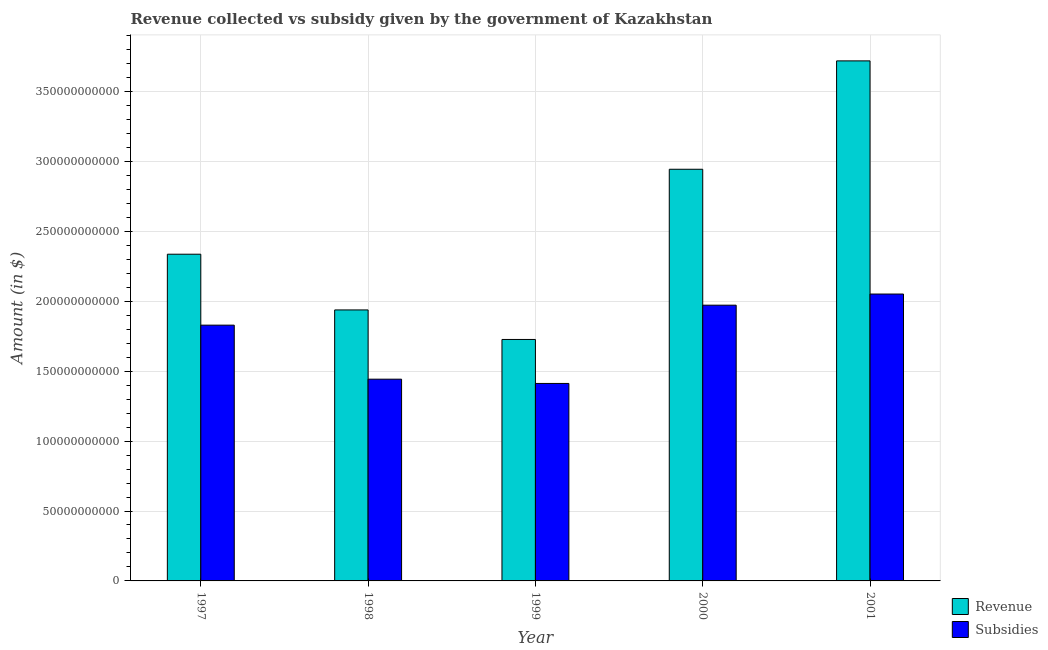How many different coloured bars are there?
Provide a short and direct response. 2. Are the number of bars on each tick of the X-axis equal?
Give a very brief answer. Yes. How many bars are there on the 3rd tick from the left?
Keep it short and to the point. 2. How many bars are there on the 1st tick from the right?
Offer a very short reply. 2. What is the label of the 2nd group of bars from the left?
Your answer should be compact. 1998. What is the amount of subsidies given in 1999?
Give a very brief answer. 1.41e+11. Across all years, what is the maximum amount of subsidies given?
Ensure brevity in your answer.  2.05e+11. Across all years, what is the minimum amount of revenue collected?
Ensure brevity in your answer.  1.73e+11. In which year was the amount of revenue collected maximum?
Ensure brevity in your answer.  2001. What is the total amount of revenue collected in the graph?
Provide a succinct answer. 1.27e+12. What is the difference between the amount of subsidies given in 1998 and that in 2000?
Your response must be concise. -5.29e+1. What is the difference between the amount of subsidies given in 1997 and the amount of revenue collected in 2001?
Your answer should be compact. -2.23e+1. What is the average amount of subsidies given per year?
Make the answer very short. 1.74e+11. In the year 2000, what is the difference between the amount of subsidies given and amount of revenue collected?
Provide a succinct answer. 0. What is the ratio of the amount of subsidies given in 2000 to that in 2001?
Make the answer very short. 0.96. Is the amount of revenue collected in 1999 less than that in 2000?
Provide a succinct answer. Yes. What is the difference between the highest and the second highest amount of revenue collected?
Make the answer very short. 7.75e+1. What is the difference between the highest and the lowest amount of revenue collected?
Make the answer very short. 1.99e+11. What does the 2nd bar from the left in 1999 represents?
Provide a succinct answer. Subsidies. What does the 1st bar from the right in 1998 represents?
Provide a succinct answer. Subsidies. How many bars are there?
Keep it short and to the point. 10. How many years are there in the graph?
Your answer should be compact. 5. Are the values on the major ticks of Y-axis written in scientific E-notation?
Your response must be concise. No. Does the graph contain grids?
Keep it short and to the point. Yes. What is the title of the graph?
Provide a short and direct response. Revenue collected vs subsidy given by the government of Kazakhstan. Does "From World Bank" appear as one of the legend labels in the graph?
Provide a short and direct response. No. What is the label or title of the Y-axis?
Keep it short and to the point. Amount (in $). What is the Amount (in $) of Revenue in 1997?
Provide a succinct answer. 2.34e+11. What is the Amount (in $) of Subsidies in 1997?
Keep it short and to the point. 1.83e+11. What is the Amount (in $) in Revenue in 1998?
Your answer should be very brief. 1.94e+11. What is the Amount (in $) of Subsidies in 1998?
Provide a succinct answer. 1.44e+11. What is the Amount (in $) in Revenue in 1999?
Offer a very short reply. 1.73e+11. What is the Amount (in $) of Subsidies in 1999?
Ensure brevity in your answer.  1.41e+11. What is the Amount (in $) of Revenue in 2000?
Offer a terse response. 2.94e+11. What is the Amount (in $) in Subsidies in 2000?
Give a very brief answer. 1.97e+11. What is the Amount (in $) of Revenue in 2001?
Your answer should be very brief. 3.72e+11. What is the Amount (in $) in Subsidies in 2001?
Your answer should be very brief. 2.05e+11. Across all years, what is the maximum Amount (in $) in Revenue?
Provide a short and direct response. 3.72e+11. Across all years, what is the maximum Amount (in $) in Subsidies?
Ensure brevity in your answer.  2.05e+11. Across all years, what is the minimum Amount (in $) in Revenue?
Ensure brevity in your answer.  1.73e+11. Across all years, what is the minimum Amount (in $) of Subsidies?
Keep it short and to the point. 1.41e+11. What is the total Amount (in $) in Revenue in the graph?
Your answer should be very brief. 1.27e+12. What is the total Amount (in $) in Subsidies in the graph?
Provide a succinct answer. 8.71e+11. What is the difference between the Amount (in $) in Revenue in 1997 and that in 1998?
Offer a terse response. 3.99e+1. What is the difference between the Amount (in $) of Subsidies in 1997 and that in 1998?
Make the answer very short. 3.86e+1. What is the difference between the Amount (in $) of Revenue in 1997 and that in 1999?
Offer a very short reply. 6.10e+1. What is the difference between the Amount (in $) of Subsidies in 1997 and that in 1999?
Give a very brief answer. 4.17e+1. What is the difference between the Amount (in $) of Revenue in 1997 and that in 2000?
Provide a short and direct response. -6.08e+1. What is the difference between the Amount (in $) in Subsidies in 1997 and that in 2000?
Your answer should be compact. -1.43e+1. What is the difference between the Amount (in $) in Revenue in 1997 and that in 2001?
Make the answer very short. -1.38e+11. What is the difference between the Amount (in $) of Subsidies in 1997 and that in 2001?
Keep it short and to the point. -2.23e+1. What is the difference between the Amount (in $) of Revenue in 1998 and that in 1999?
Make the answer very short. 2.11e+1. What is the difference between the Amount (in $) of Subsidies in 1998 and that in 1999?
Keep it short and to the point. 3.05e+09. What is the difference between the Amount (in $) in Revenue in 1998 and that in 2000?
Offer a terse response. -1.01e+11. What is the difference between the Amount (in $) in Subsidies in 1998 and that in 2000?
Give a very brief answer. -5.29e+1. What is the difference between the Amount (in $) of Revenue in 1998 and that in 2001?
Your answer should be compact. -1.78e+11. What is the difference between the Amount (in $) of Subsidies in 1998 and that in 2001?
Ensure brevity in your answer.  -6.09e+1. What is the difference between the Amount (in $) of Revenue in 1999 and that in 2000?
Provide a short and direct response. -1.22e+11. What is the difference between the Amount (in $) in Subsidies in 1999 and that in 2000?
Ensure brevity in your answer.  -5.60e+1. What is the difference between the Amount (in $) in Revenue in 1999 and that in 2001?
Give a very brief answer. -1.99e+11. What is the difference between the Amount (in $) of Subsidies in 1999 and that in 2001?
Give a very brief answer. -6.40e+1. What is the difference between the Amount (in $) in Revenue in 2000 and that in 2001?
Provide a succinct answer. -7.75e+1. What is the difference between the Amount (in $) in Subsidies in 2000 and that in 2001?
Ensure brevity in your answer.  -7.97e+09. What is the difference between the Amount (in $) in Revenue in 1997 and the Amount (in $) in Subsidies in 1998?
Provide a succinct answer. 8.94e+1. What is the difference between the Amount (in $) of Revenue in 1997 and the Amount (in $) of Subsidies in 1999?
Ensure brevity in your answer.  9.24e+1. What is the difference between the Amount (in $) in Revenue in 1997 and the Amount (in $) in Subsidies in 2000?
Provide a short and direct response. 3.65e+1. What is the difference between the Amount (in $) of Revenue in 1997 and the Amount (in $) of Subsidies in 2001?
Your answer should be compact. 2.85e+1. What is the difference between the Amount (in $) of Revenue in 1998 and the Amount (in $) of Subsidies in 1999?
Make the answer very short. 5.26e+1. What is the difference between the Amount (in $) in Revenue in 1998 and the Amount (in $) in Subsidies in 2000?
Your answer should be compact. -3.40e+09. What is the difference between the Amount (in $) of Revenue in 1998 and the Amount (in $) of Subsidies in 2001?
Offer a very short reply. -1.14e+1. What is the difference between the Amount (in $) in Revenue in 1999 and the Amount (in $) in Subsidies in 2000?
Offer a terse response. -2.45e+1. What is the difference between the Amount (in $) of Revenue in 1999 and the Amount (in $) of Subsidies in 2001?
Your answer should be compact. -3.25e+1. What is the difference between the Amount (in $) of Revenue in 2000 and the Amount (in $) of Subsidies in 2001?
Make the answer very short. 8.93e+1. What is the average Amount (in $) in Revenue per year?
Give a very brief answer. 2.53e+11. What is the average Amount (in $) in Subsidies per year?
Your answer should be very brief. 1.74e+11. In the year 1997, what is the difference between the Amount (in $) in Revenue and Amount (in $) in Subsidies?
Your response must be concise. 5.07e+1. In the year 1998, what is the difference between the Amount (in $) of Revenue and Amount (in $) of Subsidies?
Offer a terse response. 4.95e+1. In the year 1999, what is the difference between the Amount (in $) of Revenue and Amount (in $) of Subsidies?
Give a very brief answer. 3.15e+1. In the year 2000, what is the difference between the Amount (in $) in Revenue and Amount (in $) in Subsidies?
Provide a short and direct response. 9.72e+1. In the year 2001, what is the difference between the Amount (in $) in Revenue and Amount (in $) in Subsidies?
Give a very brief answer. 1.67e+11. What is the ratio of the Amount (in $) of Revenue in 1997 to that in 1998?
Your response must be concise. 1.21. What is the ratio of the Amount (in $) of Subsidies in 1997 to that in 1998?
Offer a very short reply. 1.27. What is the ratio of the Amount (in $) in Revenue in 1997 to that in 1999?
Provide a short and direct response. 1.35. What is the ratio of the Amount (in $) in Subsidies in 1997 to that in 1999?
Keep it short and to the point. 1.3. What is the ratio of the Amount (in $) in Revenue in 1997 to that in 2000?
Offer a very short reply. 0.79. What is the ratio of the Amount (in $) in Subsidies in 1997 to that in 2000?
Provide a succinct answer. 0.93. What is the ratio of the Amount (in $) of Revenue in 1997 to that in 2001?
Give a very brief answer. 0.63. What is the ratio of the Amount (in $) of Subsidies in 1997 to that in 2001?
Make the answer very short. 0.89. What is the ratio of the Amount (in $) of Revenue in 1998 to that in 1999?
Provide a short and direct response. 1.12. What is the ratio of the Amount (in $) in Subsidies in 1998 to that in 1999?
Your answer should be compact. 1.02. What is the ratio of the Amount (in $) of Revenue in 1998 to that in 2000?
Offer a terse response. 0.66. What is the ratio of the Amount (in $) of Subsidies in 1998 to that in 2000?
Ensure brevity in your answer.  0.73. What is the ratio of the Amount (in $) in Revenue in 1998 to that in 2001?
Give a very brief answer. 0.52. What is the ratio of the Amount (in $) of Subsidies in 1998 to that in 2001?
Keep it short and to the point. 0.7. What is the ratio of the Amount (in $) of Revenue in 1999 to that in 2000?
Offer a very short reply. 0.59. What is the ratio of the Amount (in $) of Subsidies in 1999 to that in 2000?
Offer a terse response. 0.72. What is the ratio of the Amount (in $) of Revenue in 1999 to that in 2001?
Your answer should be very brief. 0.46. What is the ratio of the Amount (in $) in Subsidies in 1999 to that in 2001?
Provide a short and direct response. 0.69. What is the ratio of the Amount (in $) in Revenue in 2000 to that in 2001?
Provide a short and direct response. 0.79. What is the ratio of the Amount (in $) in Subsidies in 2000 to that in 2001?
Your answer should be very brief. 0.96. What is the difference between the highest and the second highest Amount (in $) of Revenue?
Keep it short and to the point. 7.75e+1. What is the difference between the highest and the second highest Amount (in $) of Subsidies?
Give a very brief answer. 7.97e+09. What is the difference between the highest and the lowest Amount (in $) in Revenue?
Your answer should be very brief. 1.99e+11. What is the difference between the highest and the lowest Amount (in $) in Subsidies?
Provide a succinct answer. 6.40e+1. 